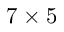<formula> <loc_0><loc_0><loc_500><loc_500>7 \times 5</formula> 